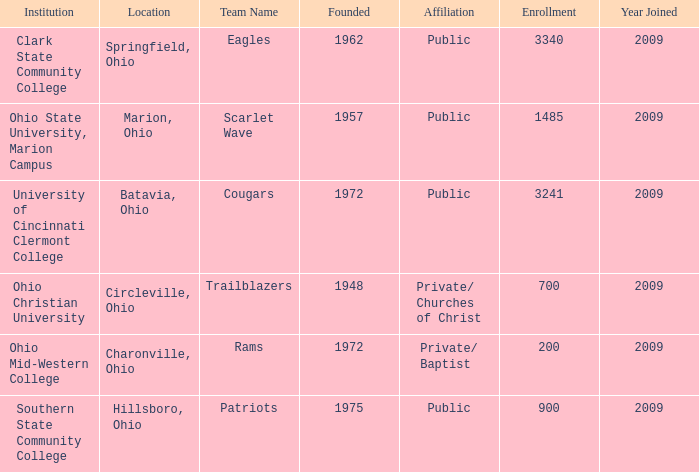What was the location for the team name of patriots? Hillsboro, Ohio. 